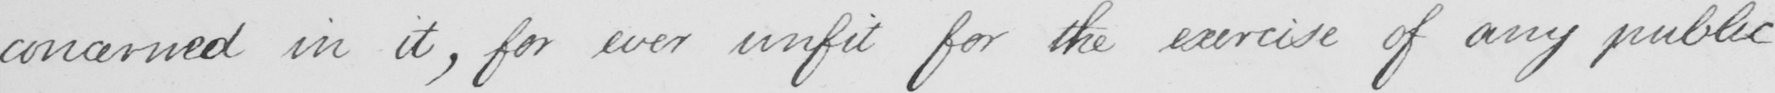Transcribe the text shown in this historical manuscript line. concerned in it , for ever unfit for the exercise of any public 